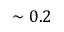<formula> <loc_0><loc_0><loc_500><loc_500>\sim 0 . 2</formula> 